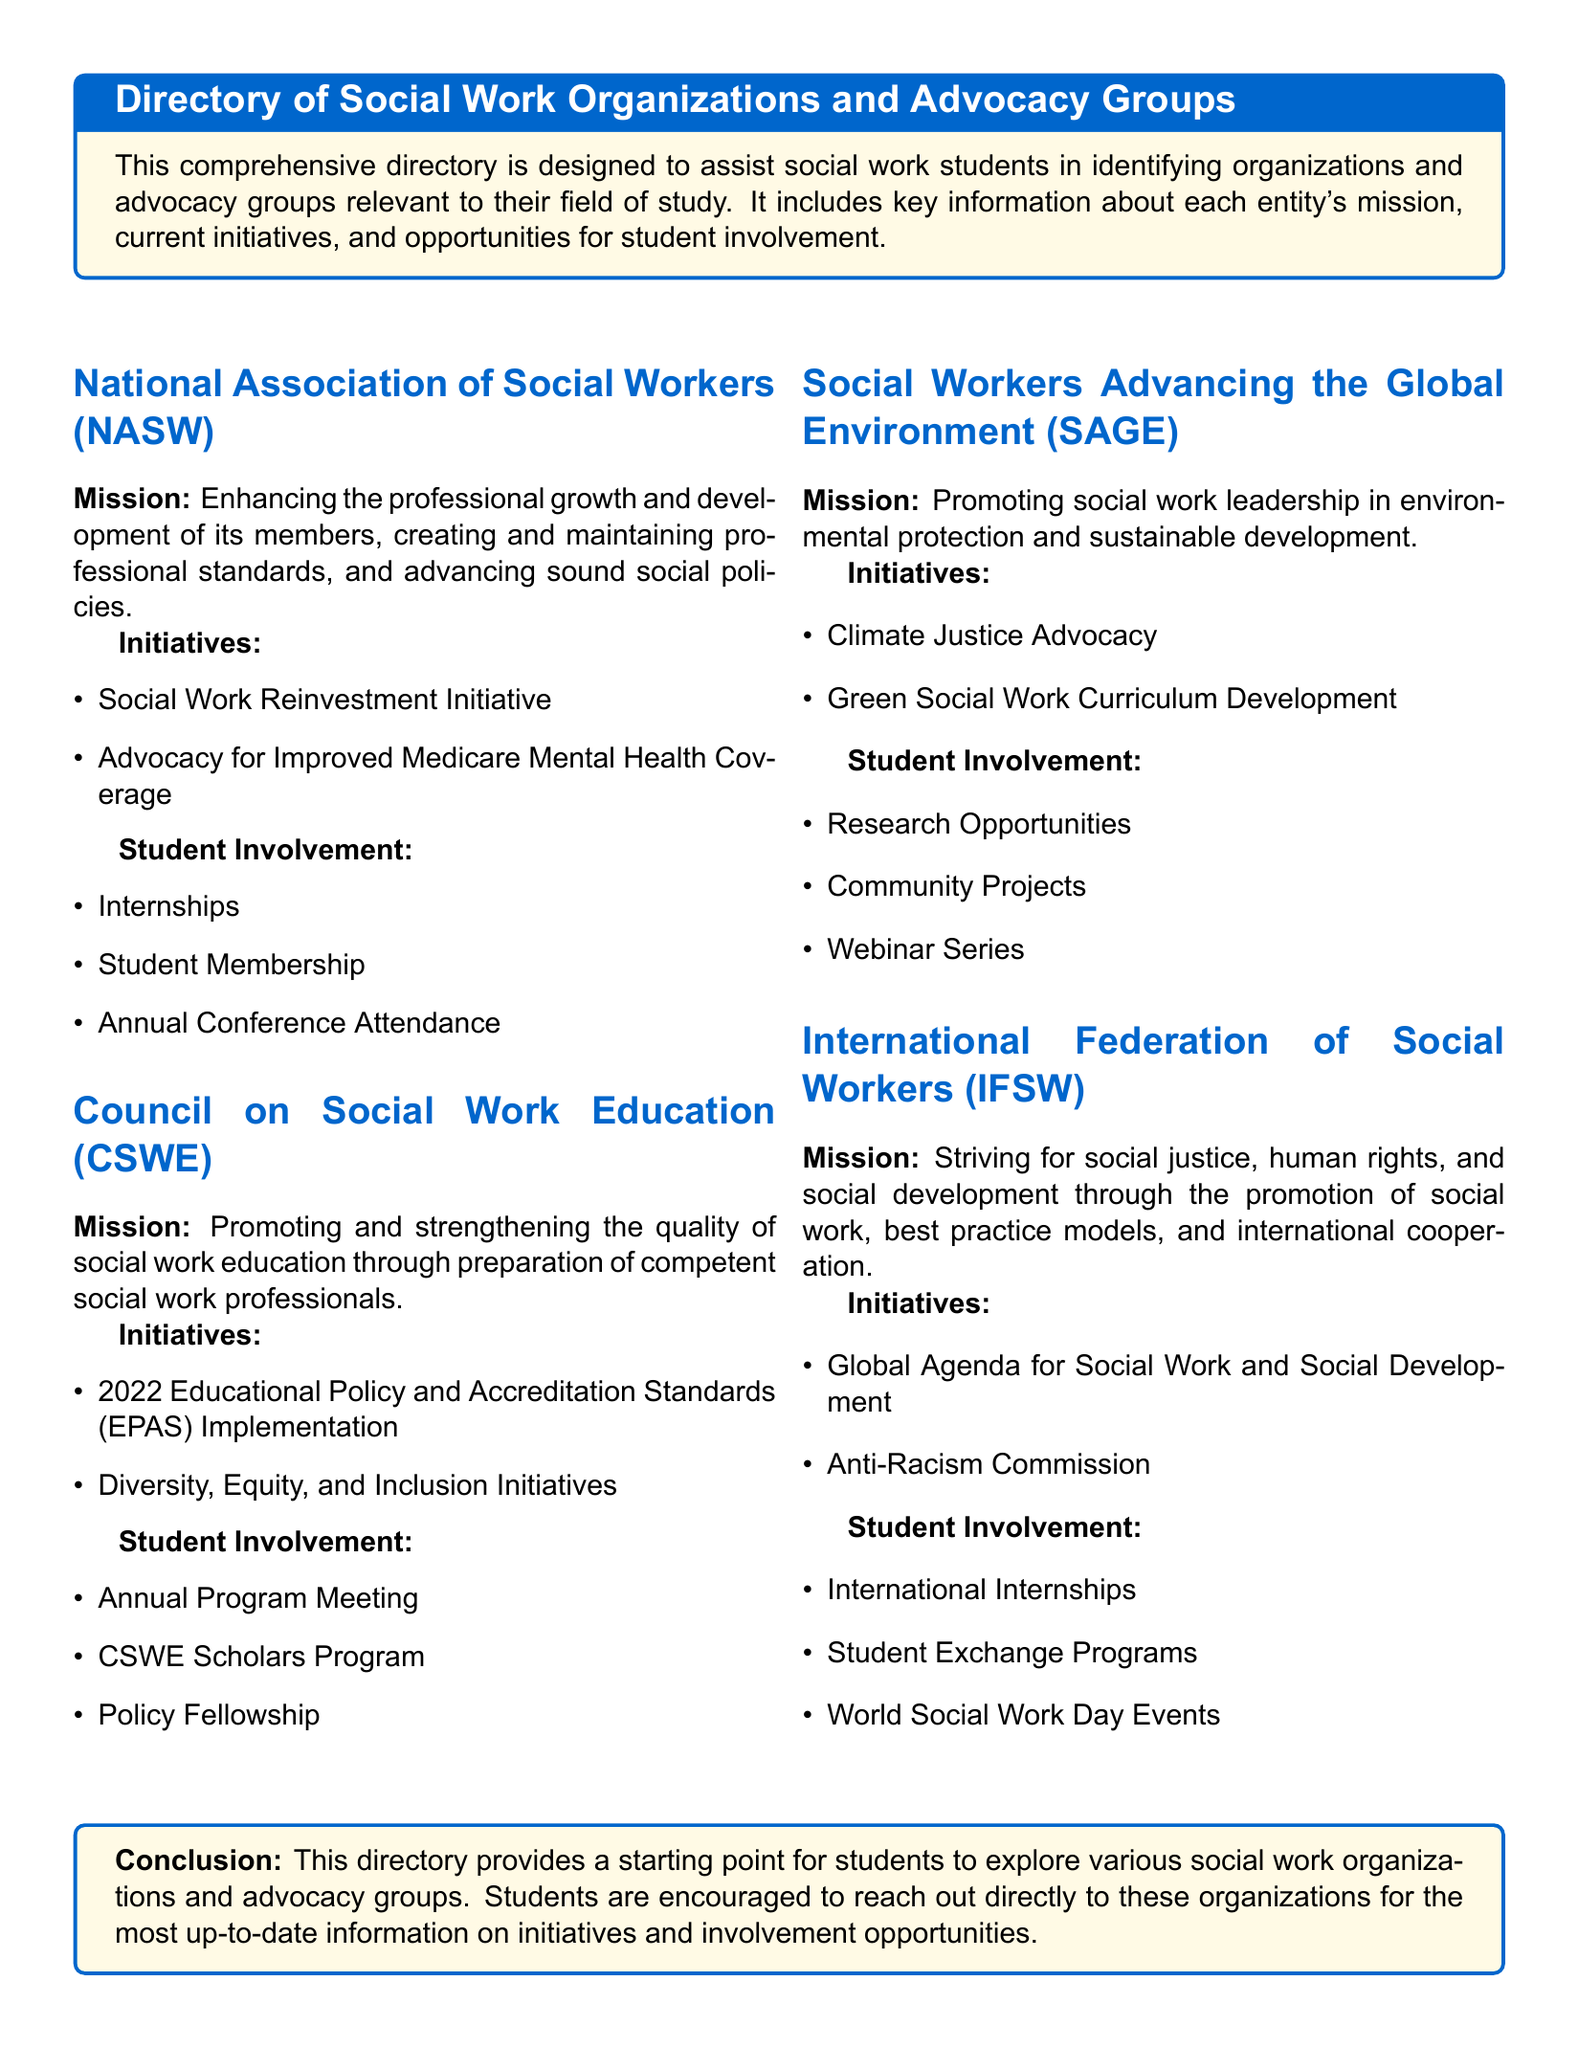what is the mission of NASW? The mission of NASW is to enhance the professional growth and development of its members, create and maintain professional standards, and advance sound social policies.
Answer: enhancing the professional growth and development of its members name one initiative of CSWE. One of the initiatives of CSWE is the implementation of the 2022 Educational Policy and Accreditation Standards.
Answer: 2022 Educational Policy and Accreditation Standards what opportunities for student involvement does SAGE offer? SAGE offers research opportunities, community projects, and a webinar series for student involvement.
Answer: Research Opportunities how many initiatives are listed for IFSW? The document lists two initiatives for IFSW, which are the Global Agenda for Social Work and Social Development and the Anti-Racism Commission.
Answer: two what is the primary focus of the Social Work Reinvestment Initiative? The primary focus of the Social Work Reinvestment Initiative involves enhancing the resources and support for the social work profession, though it is not explicitly stated in the document.
Answer: enhancing resources and support which organization promotes diversity, equity, and inclusion initiatives? The organization that promotes diversity, equity, and inclusion initiatives is the Council on Social Work Education (CSWE).
Answer: Council on Social Work Education (CSWE) what type of programs does IFSW provide for students? IFSW provides international internships and student exchange programs for students.
Answer: International Internships how does SAGE promote environmental leadership? SAGE promotes environmental leadership through initiatives like climate justice advocacy and green social work curriculum development.
Answer: climate justice advocacy what conclusion does the directory provide? The conclusion of the directory suggests that students should explore social work organizations and contact them for updated information.
Answer: explore various social work organizations 